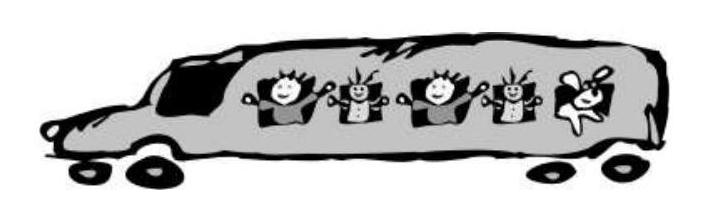How does the design of the bus reflect its purpose? The design of the bus in the image is vibrant and child-friendly, which is quite fitting for its likely purpose of transporting children. Fun and visually engaging elements like the caricatured, happy children visible through the windows suggest the vehicle is specifically designed to cater to young passengers, making the ride enjoyable and less mundane.  What safety features should be considered for a bus like this? For a bus designed to carry children, safety features are paramount. It should include seat belts for all seats, child locks on doors and windows, and appropriate safety signs and instructions visible inside the bus. Additionally, the bus should be equipped with a robust emergency response system, including first aid kits and emergency exit routes clearly marked and accessible. 